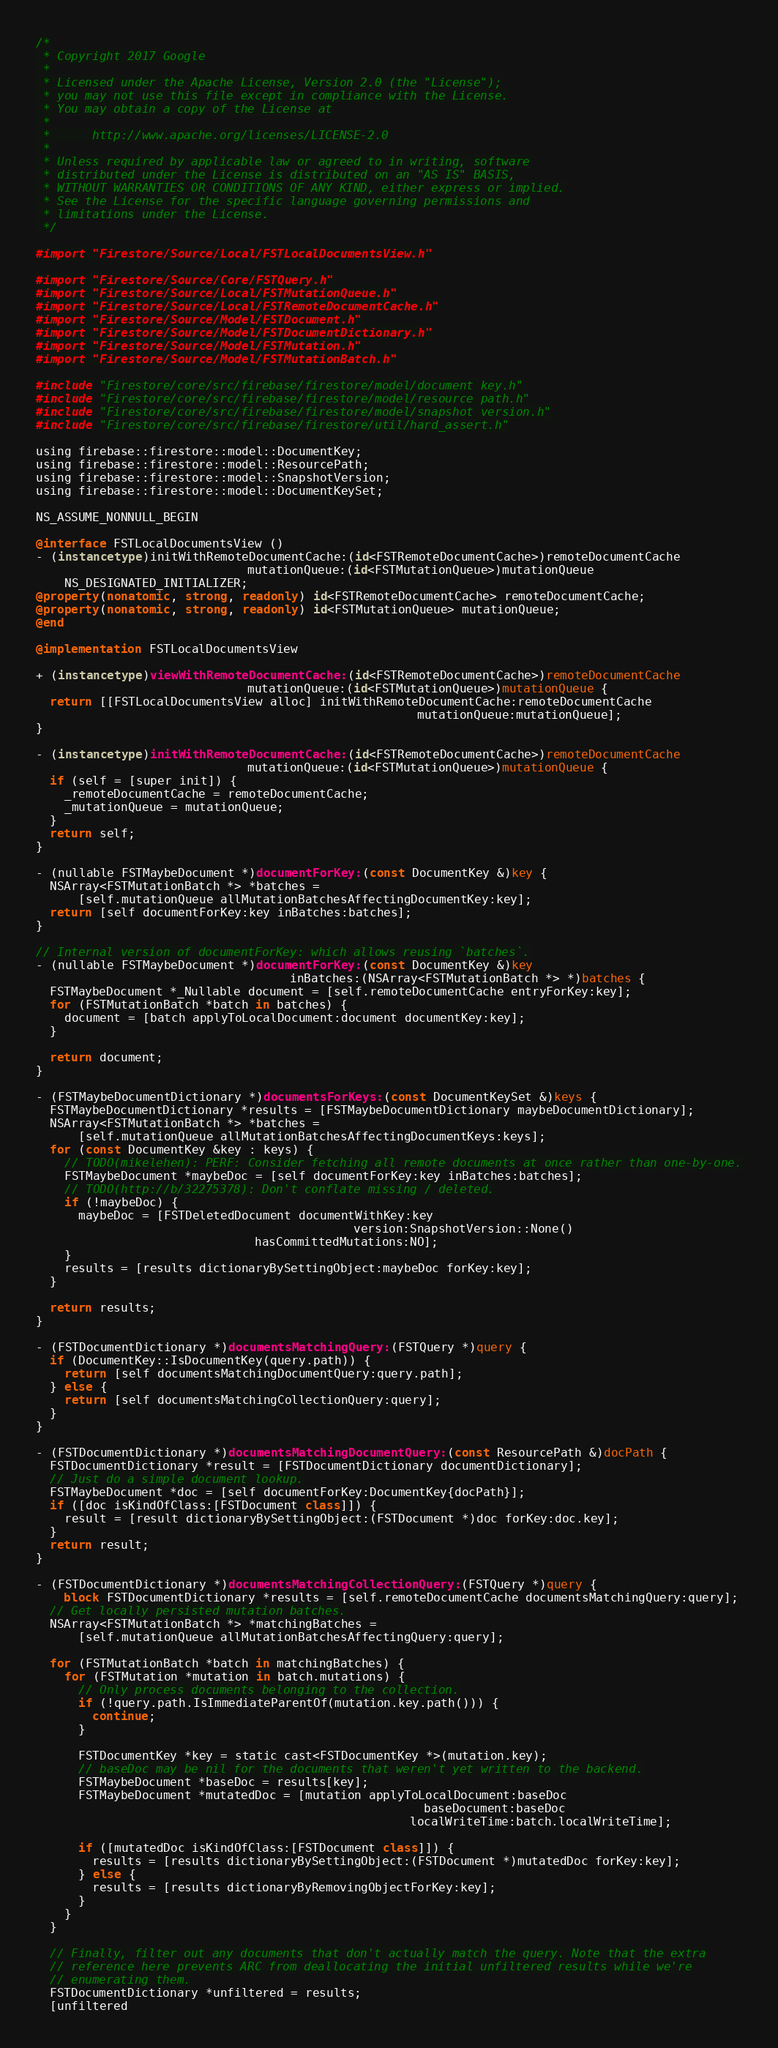Convert code to text. <code><loc_0><loc_0><loc_500><loc_500><_ObjectiveC_>/*
 * Copyright 2017 Google
 *
 * Licensed under the Apache License, Version 2.0 (the "License");
 * you may not use this file except in compliance with the License.
 * You may obtain a copy of the License at
 *
 *      http://www.apache.org/licenses/LICENSE-2.0
 *
 * Unless required by applicable law or agreed to in writing, software
 * distributed under the License is distributed on an "AS IS" BASIS,
 * WITHOUT WARRANTIES OR CONDITIONS OF ANY KIND, either express or implied.
 * See the License for the specific language governing permissions and
 * limitations under the License.
 */

#import "Firestore/Source/Local/FSTLocalDocumentsView.h"

#import "Firestore/Source/Core/FSTQuery.h"
#import "Firestore/Source/Local/FSTMutationQueue.h"
#import "Firestore/Source/Local/FSTRemoteDocumentCache.h"
#import "Firestore/Source/Model/FSTDocument.h"
#import "Firestore/Source/Model/FSTDocumentDictionary.h"
#import "Firestore/Source/Model/FSTMutation.h"
#import "Firestore/Source/Model/FSTMutationBatch.h"

#include "Firestore/core/src/firebase/firestore/model/document_key.h"
#include "Firestore/core/src/firebase/firestore/model/resource_path.h"
#include "Firestore/core/src/firebase/firestore/model/snapshot_version.h"
#include "Firestore/core/src/firebase/firestore/util/hard_assert.h"

using firebase::firestore::model::DocumentKey;
using firebase::firestore::model::ResourcePath;
using firebase::firestore::model::SnapshotVersion;
using firebase::firestore::model::DocumentKeySet;

NS_ASSUME_NONNULL_BEGIN

@interface FSTLocalDocumentsView ()
- (instancetype)initWithRemoteDocumentCache:(id<FSTRemoteDocumentCache>)remoteDocumentCache
                              mutationQueue:(id<FSTMutationQueue>)mutationQueue
    NS_DESIGNATED_INITIALIZER;
@property(nonatomic, strong, readonly) id<FSTRemoteDocumentCache> remoteDocumentCache;
@property(nonatomic, strong, readonly) id<FSTMutationQueue> mutationQueue;
@end

@implementation FSTLocalDocumentsView

+ (instancetype)viewWithRemoteDocumentCache:(id<FSTRemoteDocumentCache>)remoteDocumentCache
                              mutationQueue:(id<FSTMutationQueue>)mutationQueue {
  return [[FSTLocalDocumentsView alloc] initWithRemoteDocumentCache:remoteDocumentCache
                                                      mutationQueue:mutationQueue];
}

- (instancetype)initWithRemoteDocumentCache:(id<FSTRemoteDocumentCache>)remoteDocumentCache
                              mutationQueue:(id<FSTMutationQueue>)mutationQueue {
  if (self = [super init]) {
    _remoteDocumentCache = remoteDocumentCache;
    _mutationQueue = mutationQueue;
  }
  return self;
}

- (nullable FSTMaybeDocument *)documentForKey:(const DocumentKey &)key {
  NSArray<FSTMutationBatch *> *batches =
      [self.mutationQueue allMutationBatchesAffectingDocumentKey:key];
  return [self documentForKey:key inBatches:batches];
}

// Internal version of documentForKey: which allows reusing `batches`.
- (nullable FSTMaybeDocument *)documentForKey:(const DocumentKey &)key
                                    inBatches:(NSArray<FSTMutationBatch *> *)batches {
  FSTMaybeDocument *_Nullable document = [self.remoteDocumentCache entryForKey:key];
  for (FSTMutationBatch *batch in batches) {
    document = [batch applyToLocalDocument:document documentKey:key];
  }

  return document;
}

- (FSTMaybeDocumentDictionary *)documentsForKeys:(const DocumentKeySet &)keys {
  FSTMaybeDocumentDictionary *results = [FSTMaybeDocumentDictionary maybeDocumentDictionary];
  NSArray<FSTMutationBatch *> *batches =
      [self.mutationQueue allMutationBatchesAffectingDocumentKeys:keys];
  for (const DocumentKey &key : keys) {
    // TODO(mikelehen): PERF: Consider fetching all remote documents at once rather than one-by-one.
    FSTMaybeDocument *maybeDoc = [self documentForKey:key inBatches:batches];
    // TODO(http://b/32275378): Don't conflate missing / deleted.
    if (!maybeDoc) {
      maybeDoc = [FSTDeletedDocument documentWithKey:key
                                             version:SnapshotVersion::None()
                               hasCommittedMutations:NO];
    }
    results = [results dictionaryBySettingObject:maybeDoc forKey:key];
  }

  return results;
}

- (FSTDocumentDictionary *)documentsMatchingQuery:(FSTQuery *)query {
  if (DocumentKey::IsDocumentKey(query.path)) {
    return [self documentsMatchingDocumentQuery:query.path];
  } else {
    return [self documentsMatchingCollectionQuery:query];
  }
}

- (FSTDocumentDictionary *)documentsMatchingDocumentQuery:(const ResourcePath &)docPath {
  FSTDocumentDictionary *result = [FSTDocumentDictionary documentDictionary];
  // Just do a simple document lookup.
  FSTMaybeDocument *doc = [self documentForKey:DocumentKey{docPath}];
  if ([doc isKindOfClass:[FSTDocument class]]) {
    result = [result dictionaryBySettingObject:(FSTDocument *)doc forKey:doc.key];
  }
  return result;
}

- (FSTDocumentDictionary *)documentsMatchingCollectionQuery:(FSTQuery *)query {
  __block FSTDocumentDictionary *results = [self.remoteDocumentCache documentsMatchingQuery:query];
  // Get locally persisted mutation batches.
  NSArray<FSTMutationBatch *> *matchingBatches =
      [self.mutationQueue allMutationBatchesAffectingQuery:query];

  for (FSTMutationBatch *batch in matchingBatches) {
    for (FSTMutation *mutation in batch.mutations) {
      // Only process documents belonging to the collection.
      if (!query.path.IsImmediateParentOf(mutation.key.path())) {
        continue;
      }

      FSTDocumentKey *key = static_cast<FSTDocumentKey *>(mutation.key);
      // baseDoc may be nil for the documents that weren't yet written to the backend.
      FSTMaybeDocument *baseDoc = results[key];
      FSTMaybeDocument *mutatedDoc = [mutation applyToLocalDocument:baseDoc
                                                       baseDocument:baseDoc
                                                     localWriteTime:batch.localWriteTime];

      if ([mutatedDoc isKindOfClass:[FSTDocument class]]) {
        results = [results dictionaryBySettingObject:(FSTDocument *)mutatedDoc forKey:key];
      } else {
        results = [results dictionaryByRemovingObjectForKey:key];
      }
    }
  }

  // Finally, filter out any documents that don't actually match the query. Note that the extra
  // reference here prevents ARC from deallocating the initial unfiltered results while we're
  // enumerating them.
  FSTDocumentDictionary *unfiltered = results;
  [unfiltered</code> 